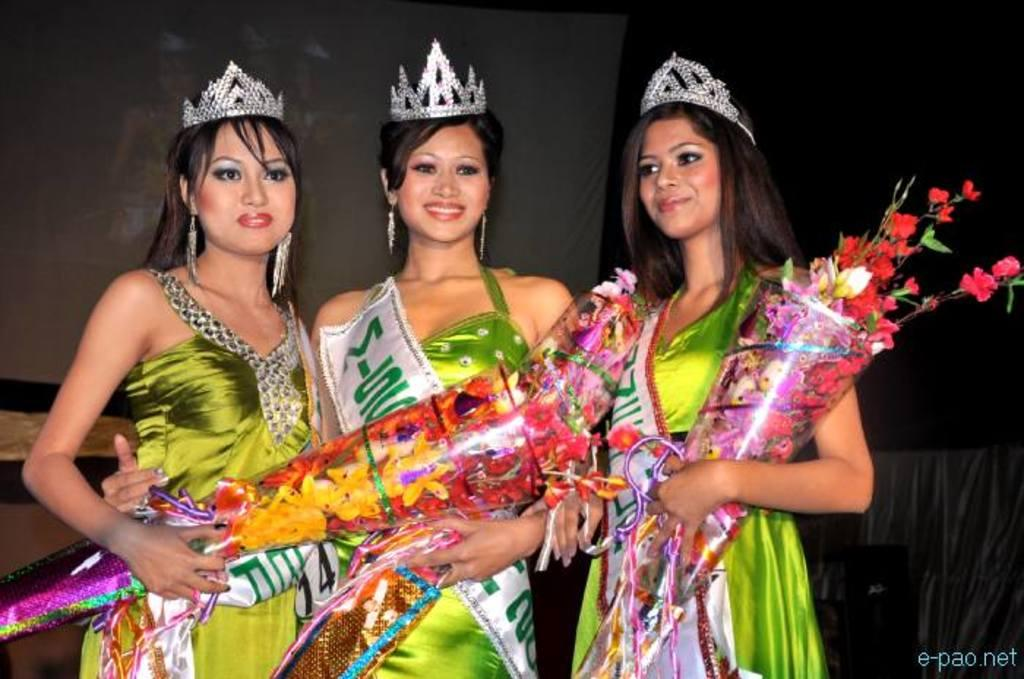How many women are in the image? There are three women in the image. What are the women wearing? The women are wearing green dresses. What are the women holding in the image? The women are holding bouquets. What expression do the women have on their faces? The women are smiling. What can be seen in the background of the image? The background of the image is dark. What type of soap can be seen in the image? There is no soap present in the image. Can you tell me which appliance the women are using in the image? There is no appliance visible in the image; the women are holding bouquets. 